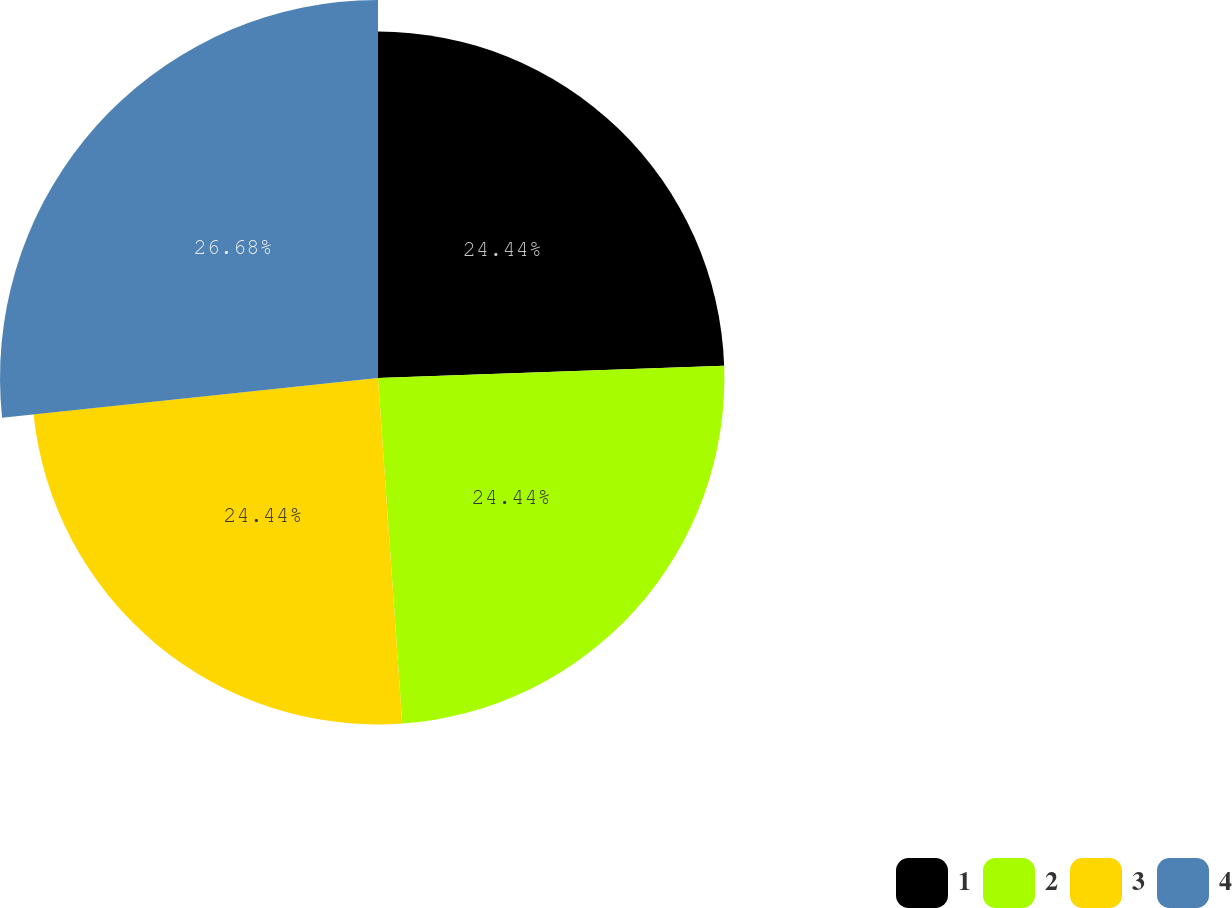<chart> <loc_0><loc_0><loc_500><loc_500><pie_chart><fcel>1<fcel>2<fcel>3<fcel>4<nl><fcel>24.44%<fcel>24.44%<fcel>24.44%<fcel>26.67%<nl></chart> 